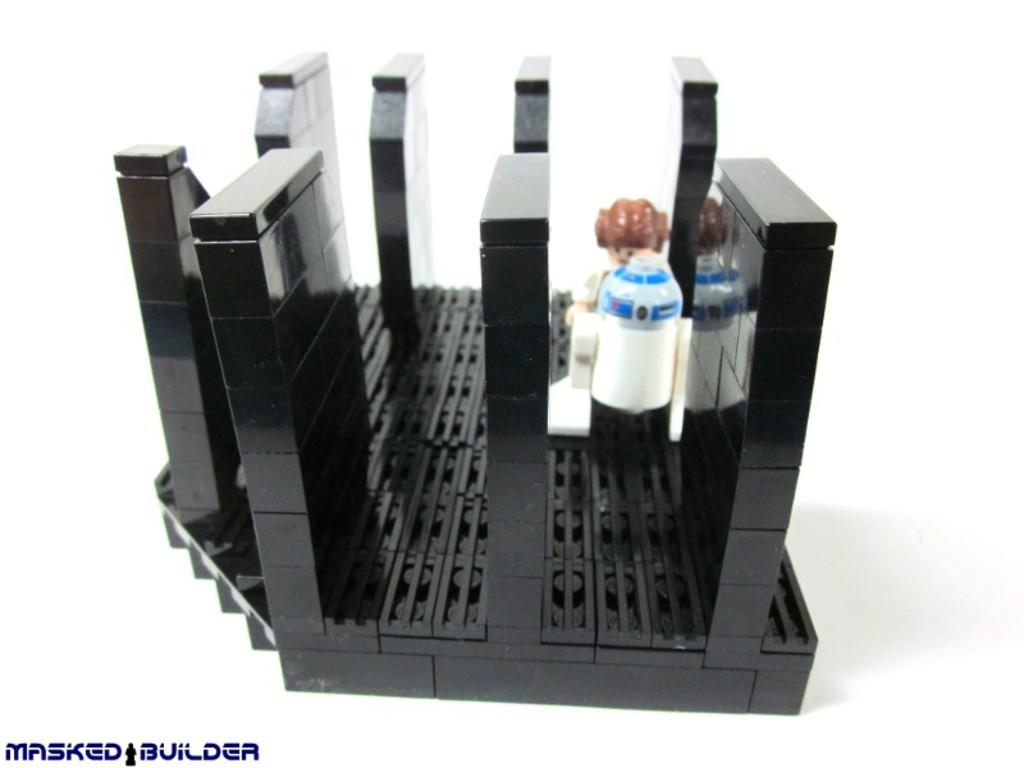<image>
Present a compact description of the photo's key features. Some small scale models and it says MASKED BUILDER on the bottom. 